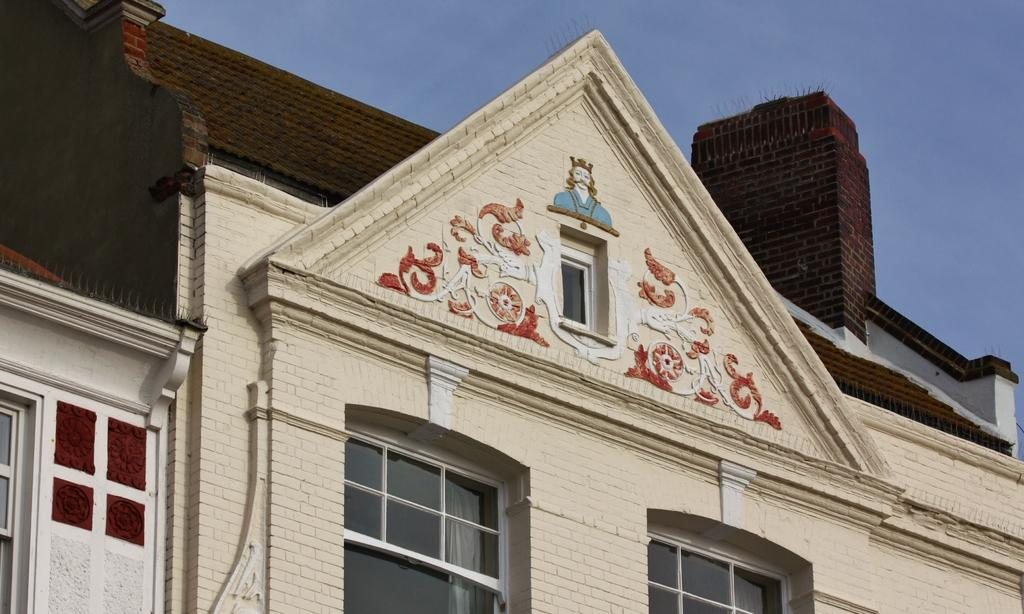What is the main structure in the image? There is a building in the image. What feature can be seen on the building? The building has windows. What else is visible in the image besides the building? The sky is visible in the image. How does the daughter interact with the building in the image? There is no daughter present in the image, so it is not possible to answer that question. 